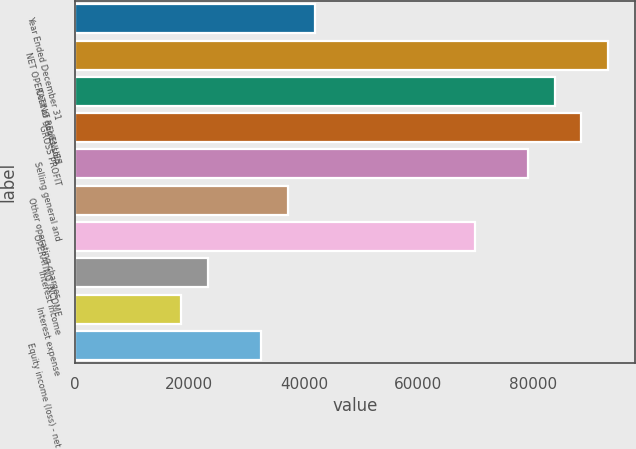Convert chart to OTSL. <chart><loc_0><loc_0><loc_500><loc_500><bar_chart><fcel>Year Ended December 31<fcel>NET OPERATING REVENUES<fcel>Cost of goods sold<fcel>GROSS PROFIT<fcel>Selling general and<fcel>Other operating charges<fcel>OPERATING INCOME<fcel>Interest income<fcel>Interest expense<fcel>Equity income (loss) - net<nl><fcel>41888.2<fcel>93080.3<fcel>83772.6<fcel>88426.5<fcel>79118.8<fcel>37234.3<fcel>69811.1<fcel>23272.8<fcel>18619<fcel>32580.5<nl></chart> 